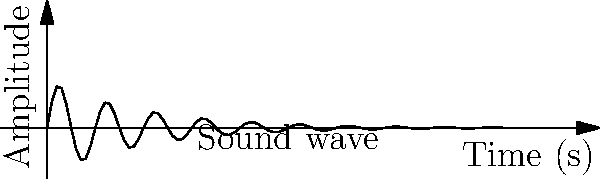In a project analyzing sound waves for a music production company, you encounter a waveform described by the function $A(t) = \sin(2\pi t) \cdot e^{-t/2}$, where $A$ is the amplitude and $t$ is time in seconds. At what time does the wave reach its first maximum amplitude after $t=0$? To find the first maximum amplitude after $t=0$, we need to follow these steps:

1) The sine function in $A(t) = \sin(2\pi t) \cdot e^{-t/2}$ determines the oscillation of the wave.

2) The maximum of $\sin(2\pi t)$ occurs when $2\pi t = \pi/2$, $5\pi/2$, $9\pi/2$, etc.

3) We're interested in the first maximum after $t=0$, so we'll use $2\pi t = \pi/2$.

4) Solve for $t$:
   $2\pi t = \pi/2$
   $t = \frac{\pi/2}{2\pi} = \frac{1}{4}$

5) Therefore, the first maximum occurs at $t = 0.25$ seconds.

6) Note: The exponential factor $e^{-t/2}$ affects the amplitude over time but doesn't change the location of the maxima determined by the sine function.
Answer: 0.25 seconds 